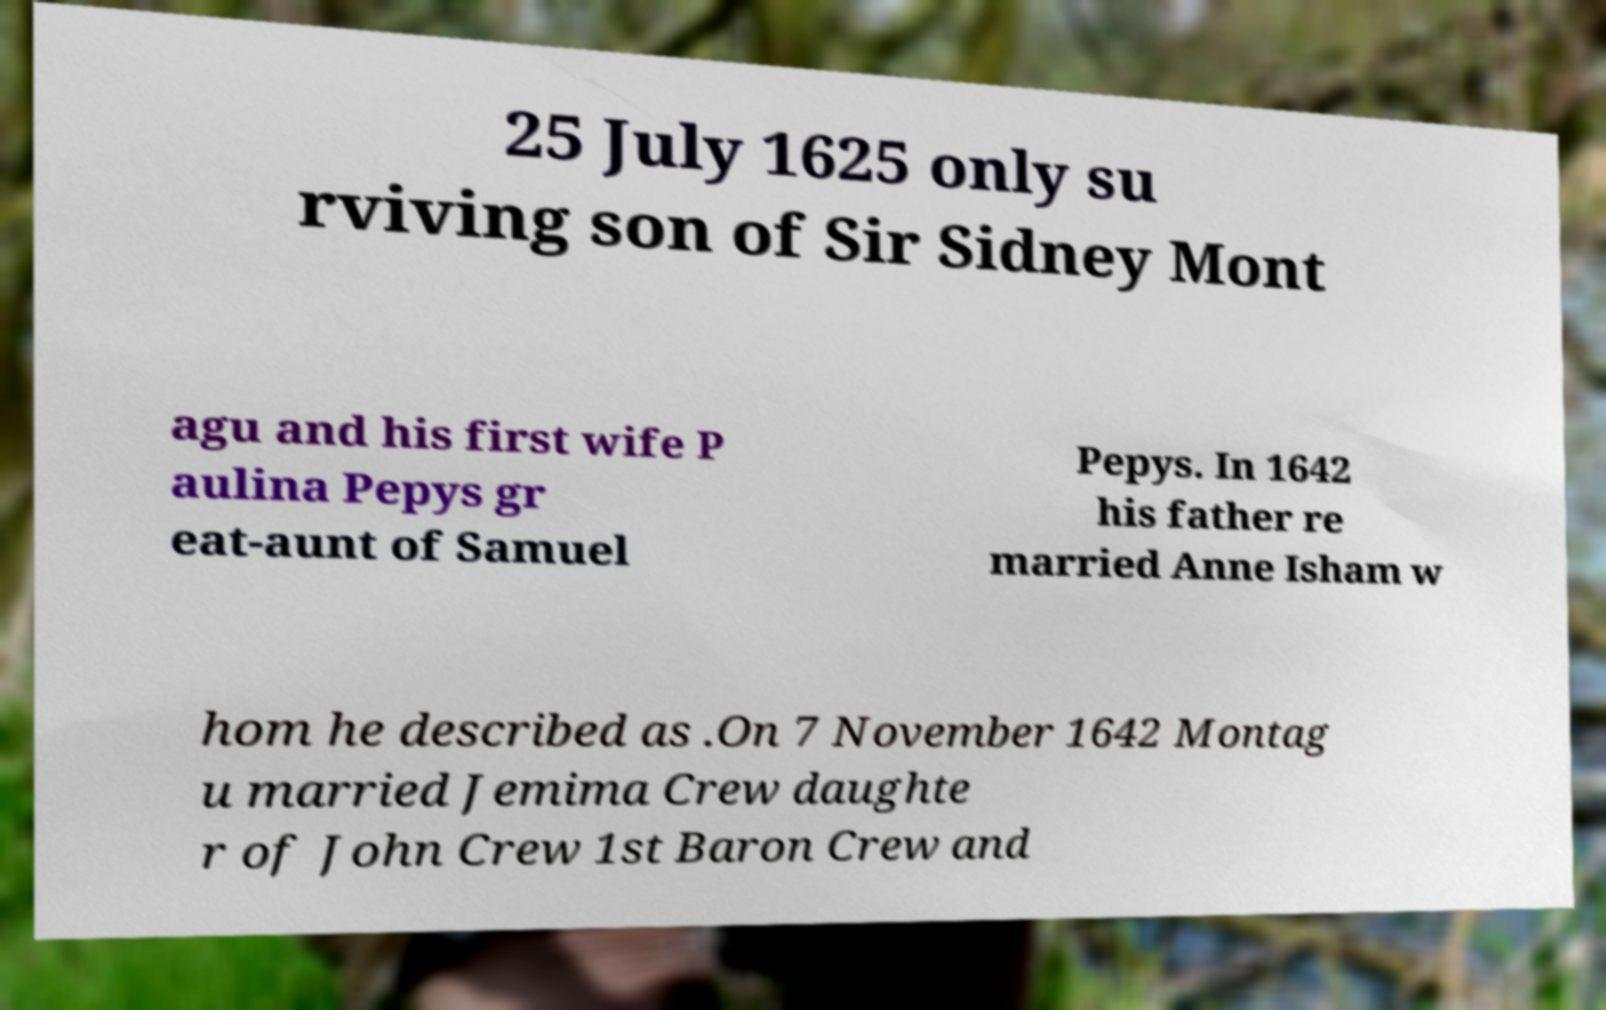Could you extract and type out the text from this image? 25 July 1625 only su rviving son of Sir Sidney Mont agu and his first wife P aulina Pepys gr eat-aunt of Samuel Pepys. In 1642 his father re married Anne Isham w hom he described as .On 7 November 1642 Montag u married Jemima Crew daughte r of John Crew 1st Baron Crew and 